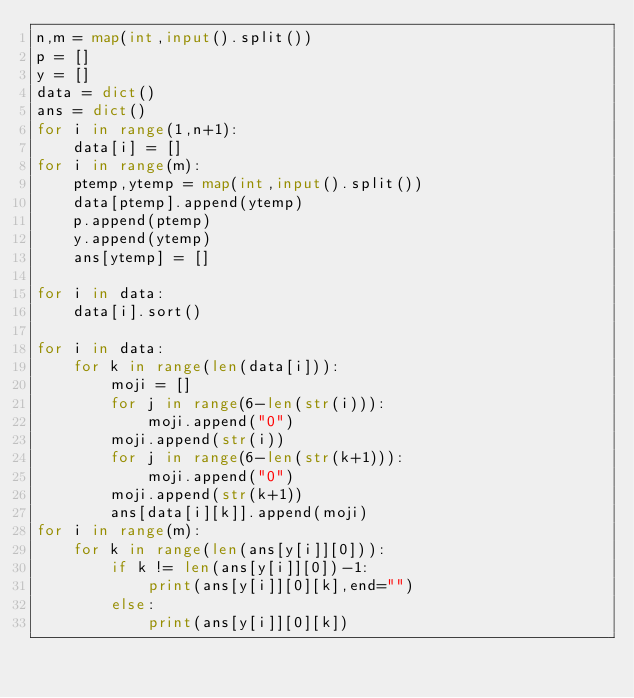<code> <loc_0><loc_0><loc_500><loc_500><_Python_>n,m = map(int,input().split())
p = []
y = []
data = dict()
ans = dict()
for i in range(1,n+1):
    data[i] = []
for i in range(m):
    ptemp,ytemp = map(int,input().split())
    data[ptemp].append(ytemp)
    p.append(ptemp)
    y.append(ytemp)
    ans[ytemp] = []

for i in data:
    data[i].sort()

for i in data:
    for k in range(len(data[i])):
        moji = []
        for j in range(6-len(str(i))):
            moji.append("0")
        moji.append(str(i))
        for j in range(6-len(str(k+1))):
            moji.append("0")
        moji.append(str(k+1))
        ans[data[i][k]].append(moji)
for i in range(m):
    for k in range(len(ans[y[i]][0])):
        if k != len(ans[y[i]][0])-1:
            print(ans[y[i]][0][k],end="")
        else:
            print(ans[y[i]][0][k])
</code> 